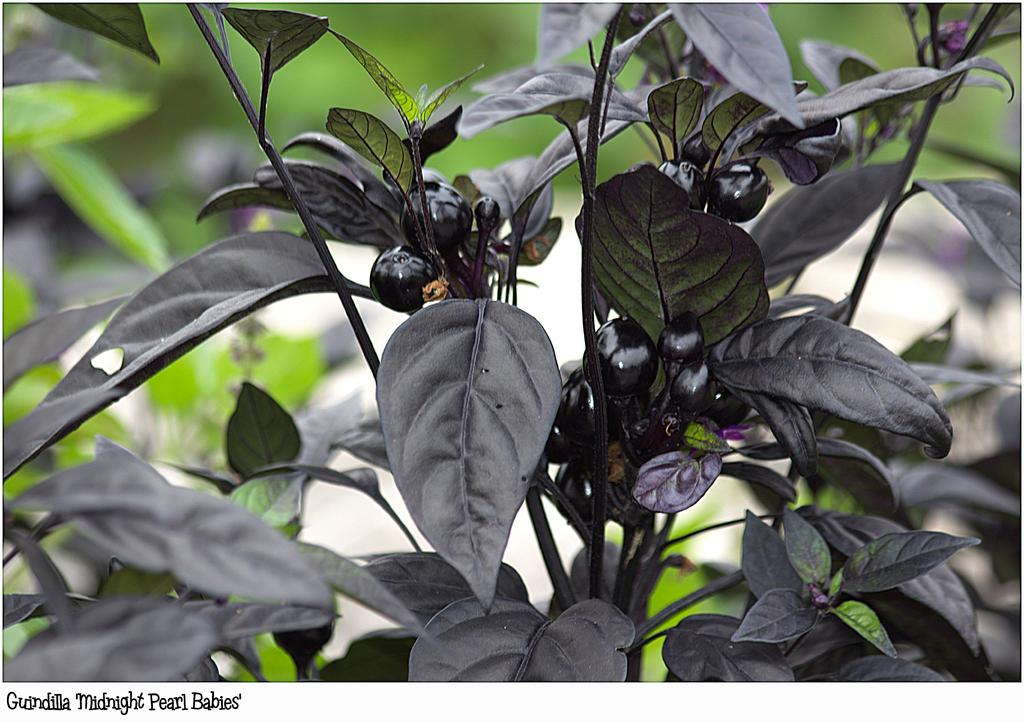What is the main subject of the image? The main subject of the image is a plant. What specific features can be observed on the plant? The plant has berries and leaves. Can you describe the background of the image? The background of the image is blurred. How does the plant express anger in the image? Plants do not express emotions like anger, so this cannot be observed in the image. 